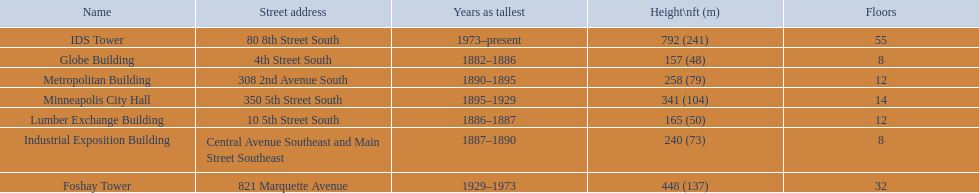What are the tallest buildings in minneapolis? Globe Building, Lumber Exchange Building, Industrial Exposition Building, Metropolitan Building, Minneapolis City Hall, Foshay Tower, IDS Tower. What is the height of the metropolitan building? 258 (79). What is the height of the lumber exchange building? 165 (50). Of those two which is taller? Metropolitan Building. 